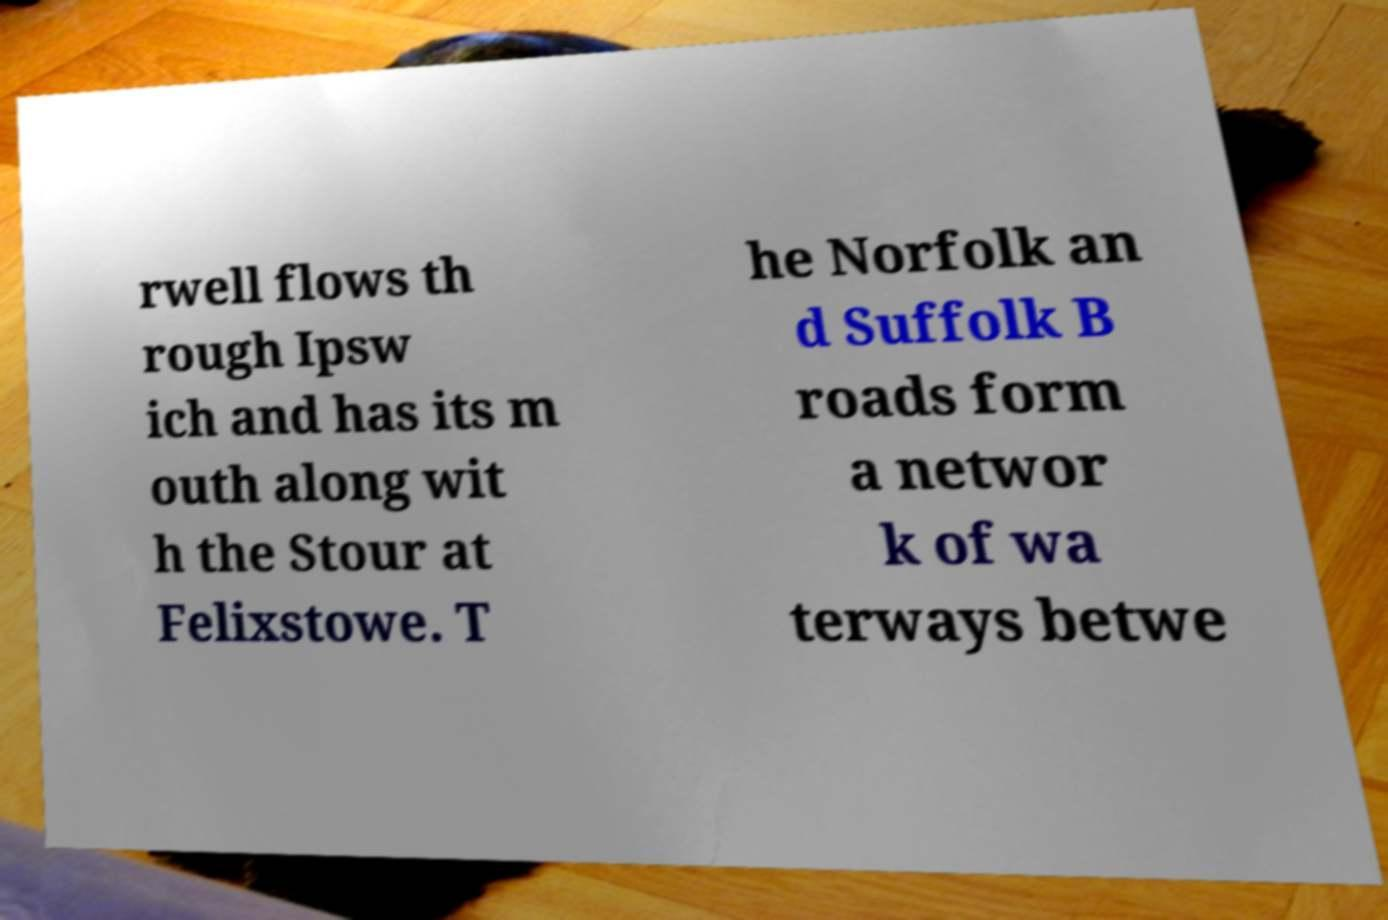I need the written content from this picture converted into text. Can you do that? rwell flows th rough Ipsw ich and has its m outh along wit h the Stour at Felixstowe. T he Norfolk an d Suffolk B roads form a networ k of wa terways betwe 